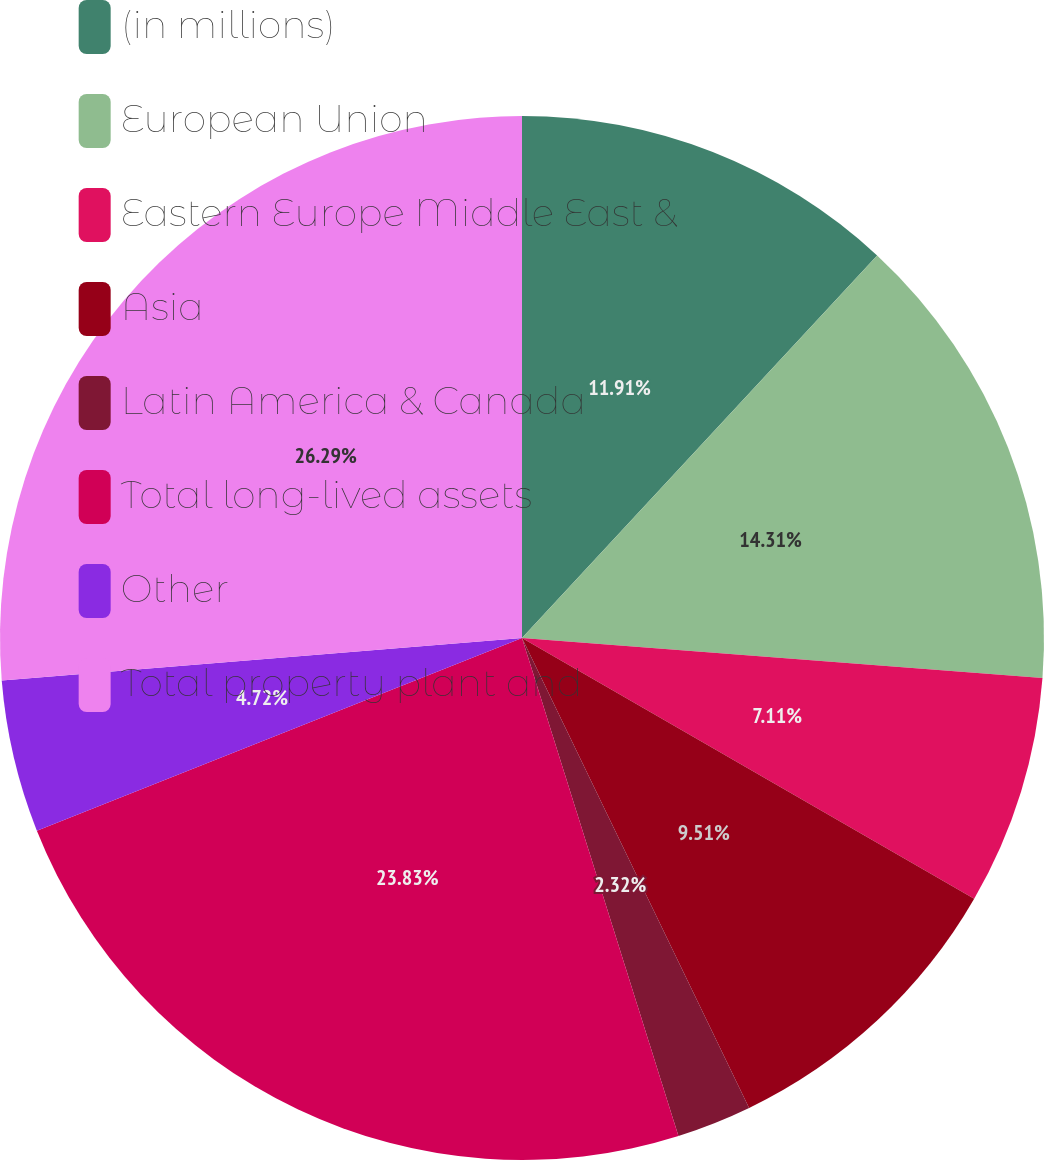Convert chart to OTSL. <chart><loc_0><loc_0><loc_500><loc_500><pie_chart><fcel>(in millions)<fcel>European Union<fcel>Eastern Europe Middle East &<fcel>Asia<fcel>Latin America & Canada<fcel>Total long-lived assets<fcel>Other<fcel>Total property plant and<nl><fcel>11.91%<fcel>14.31%<fcel>7.11%<fcel>9.51%<fcel>2.32%<fcel>23.83%<fcel>4.72%<fcel>26.3%<nl></chart> 